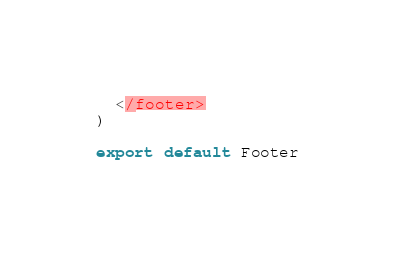<code> <loc_0><loc_0><loc_500><loc_500><_JavaScript_>  </footer>
)

export default Footer
</code> 